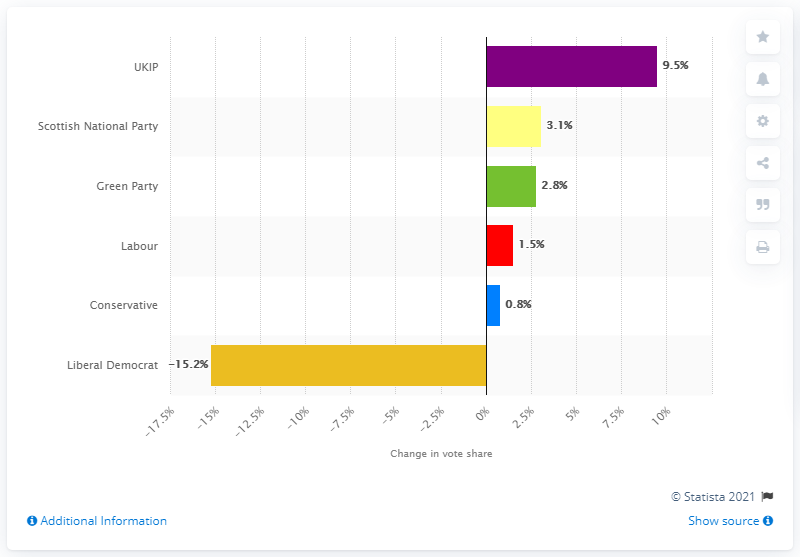List a handful of essential elements in this visual. The Green Party will be encouraged by the increase in votes. The SNP received significantly more votes in Scotland, with a difference of 3.1. 